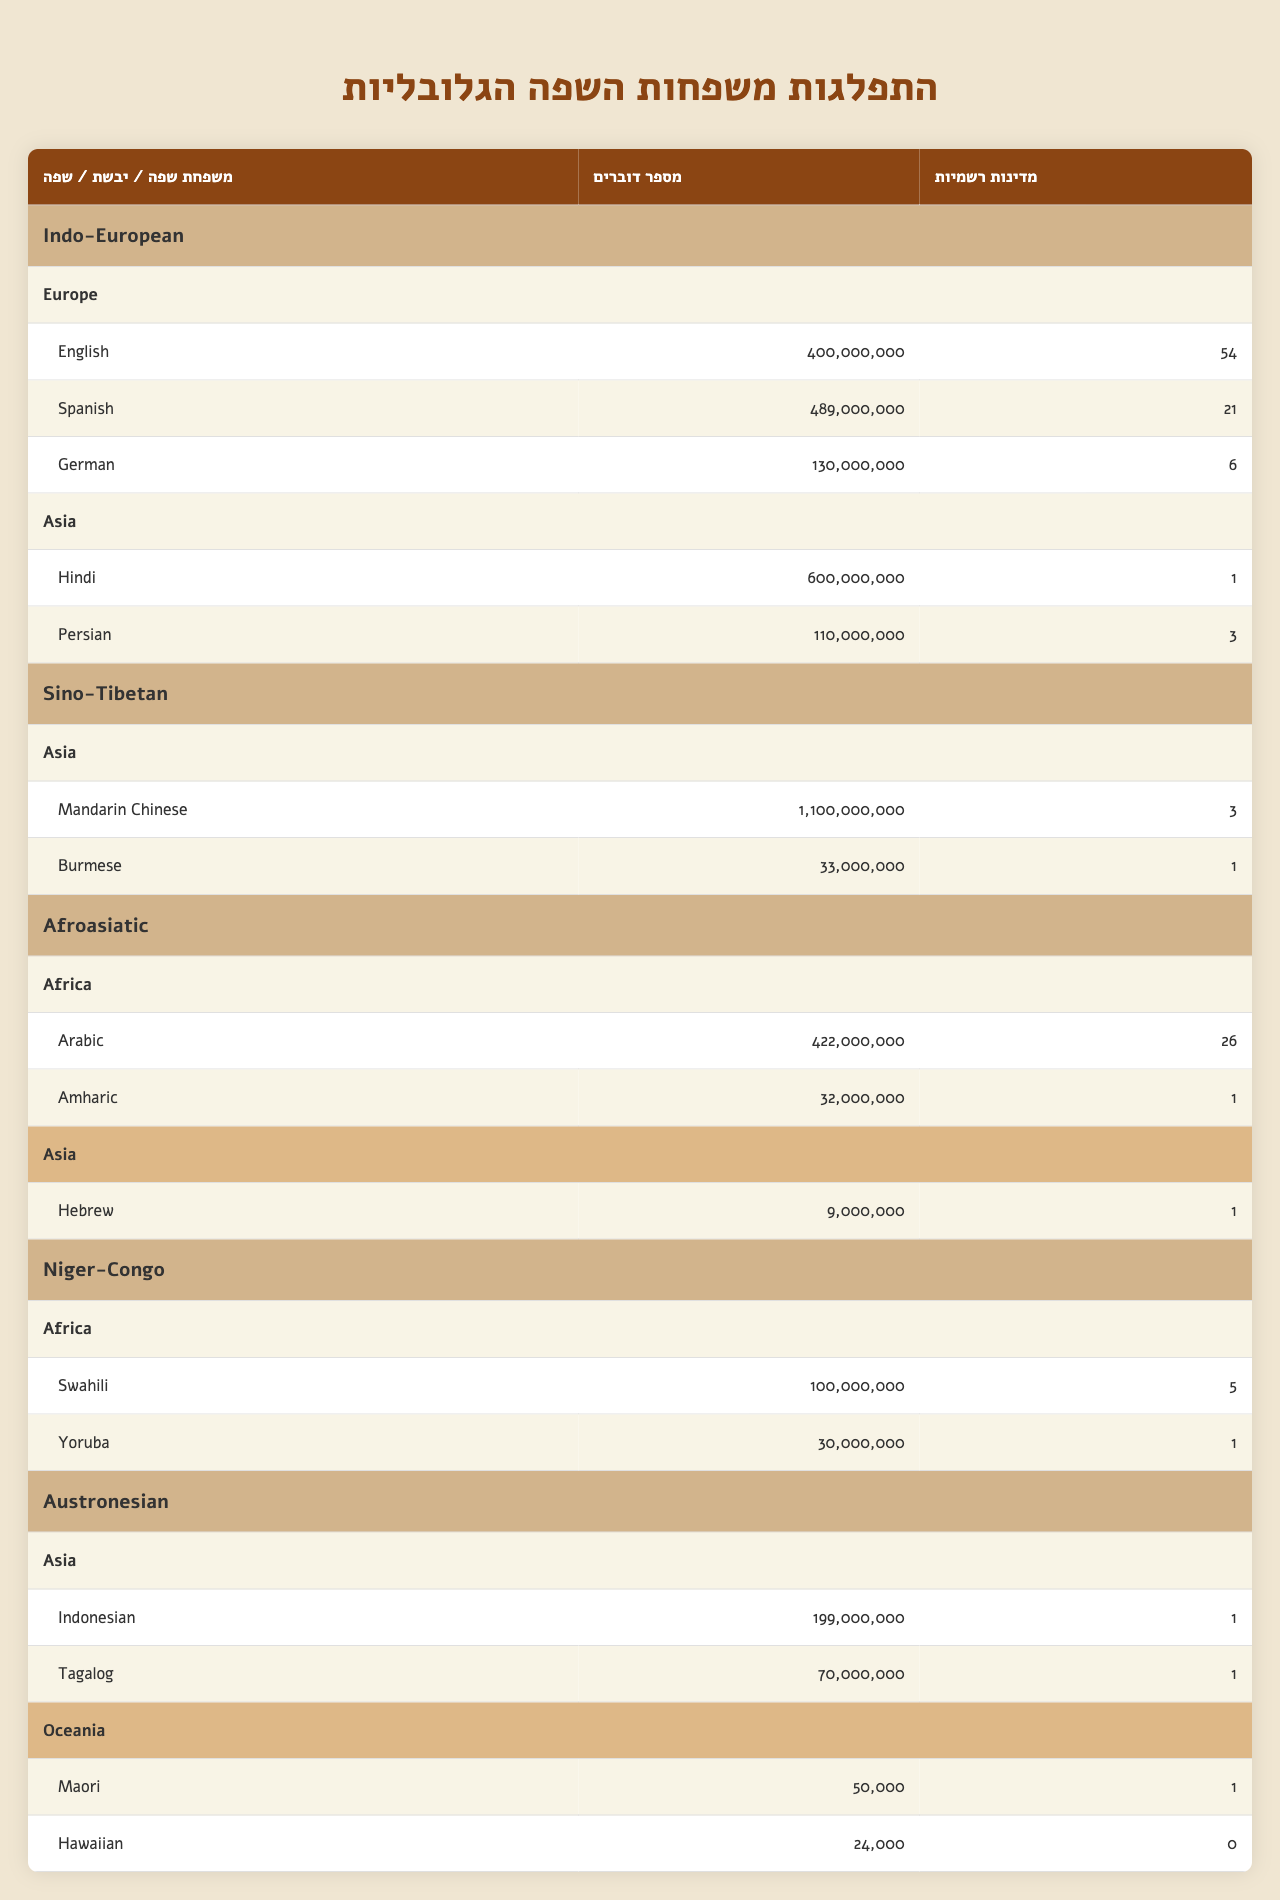What's the total number of speakers for the Indo-European family? To find the total number of speakers, we need to sum the speakers of each language under the Indo-European family: English (400,000,000), Spanish (489,000,000), German (130,000,000), Hindi (600,000,000), and Persian (110,000,000). The sum is 400,000,000 + 489,000,000 + 130,000,000 + 600,000,000 + 110,000,000 = 1,829,000,000 speakers.
Answer: 1,829,000,000 Which continent has the most languages listed? Reviewing each continent, Europe has 3 languages (English, Spanish, German), Asia has 4 languages (Hindi, Persian, Mandarin Chinese, Burmese), Africa has 2 languages (Arabic, Amharic), and Oceania has 2 languages (Maori, Hawaiian). Thus, Asia has the most languages listed with 4.
Answer: Asia Is Arabic an official language in more countries than Swahili? Arabic is an official language in 26 countries, while Swahili is official in 5 countries. Since 26 is more than 5, the statement is true.
Answer: Yes What's the combined number of speakers for African language families listed in the table? We need to sum the speakers from the Afroasiatic and Niger-Congo families. For Afroasiatic, there are 422,000,000 (Arabic) + 32,000,000 (Amharic) = 454,000,000 speakers. For Niger-Congo, there are 100,000,000 (Swahili) + 30,000,000 (Yoruba) = 130,000,000 speakers. The combined total is 454,000,000 + 130,000,000 = 584,000,000 speakers.
Answer: 584,000,000 How many more official countries does Arabic have than Hebrew? Arabic has 26 official countries, and Hebrew has 1 official country. The difference is 26 - 1 = 25 countries.
Answer: 25 What is the percentage of speakers for Mandarin Chinese compared to the total speakers of all languages in the Sino-Tibetan family? The total number of speakers in the Sino-Tibetan family is 1,100,000,000 (Mandarin Chinese) + 33,000,000 (Burmese) = 1,133,000,000 speakers. The percentage of Mandarin Chinese speakers is (1,100,000,000 / 1,133,000,000) * 100 = 97.1%.
Answer: 97.1% Which language has the fewest speakers in the table? Looking at all the language speakers, Hawaiian has 24,000 speakers, which is the lowest compared to the others listed.
Answer: Hawaiian How many languages from the Austronesian family are spoken in Oceania? The Austronesian family has two languages listed in Oceania: Maori and Hawaiian. Thus, there are 2 languages spoken in Oceania from this family.
Answer: 2 If you combine the speakers of Tagalog and Amharic, how many do you have? The number of speakers for Tagalog is 70,000,000, and for Amharic, it's 32,000,000. The combined total is 70,000,000 + 32,000,000 = 102,000,000 speakers.
Answer: 102,000,000 Which language family is represented by only one continent? The Niger-Congo family is represented solely in Africa, having no languages listed from any other continent.
Answer: Niger-Congo 